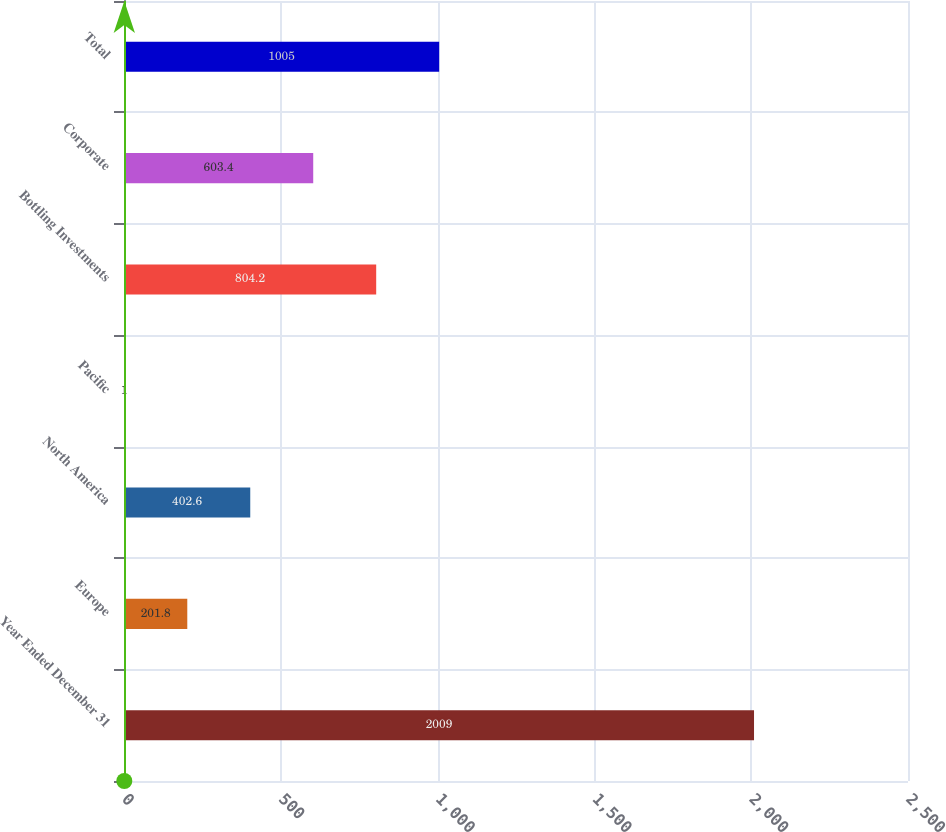Convert chart to OTSL. <chart><loc_0><loc_0><loc_500><loc_500><bar_chart><fcel>Year Ended December 31<fcel>Europe<fcel>North America<fcel>Pacific<fcel>Bottling Investments<fcel>Corporate<fcel>Total<nl><fcel>2009<fcel>201.8<fcel>402.6<fcel>1<fcel>804.2<fcel>603.4<fcel>1005<nl></chart> 